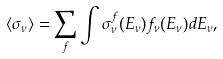Convert formula to latex. <formula><loc_0><loc_0><loc_500><loc_500>\langle \sigma _ { \nu } \rangle = \sum _ { f } \int \sigma _ { \nu } ^ { f } ( E _ { \nu } ) f _ { \nu } ( E _ { \nu } ) d E _ { \nu } ,</formula> 